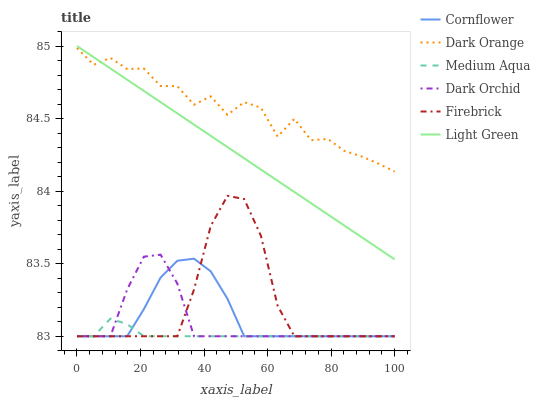Does Medium Aqua have the minimum area under the curve?
Answer yes or no. Yes. Does Dark Orange have the maximum area under the curve?
Answer yes or no. Yes. Does Firebrick have the minimum area under the curve?
Answer yes or no. No. Does Firebrick have the maximum area under the curve?
Answer yes or no. No. Is Light Green the smoothest?
Answer yes or no. Yes. Is Dark Orange the roughest?
Answer yes or no. Yes. Is Firebrick the smoothest?
Answer yes or no. No. Is Firebrick the roughest?
Answer yes or no. No. Does Cornflower have the lowest value?
Answer yes or no. Yes. Does Dark Orange have the lowest value?
Answer yes or no. No. Does Light Green have the highest value?
Answer yes or no. Yes. Does Dark Orange have the highest value?
Answer yes or no. No. Is Firebrick less than Dark Orange?
Answer yes or no. Yes. Is Dark Orange greater than Dark Orchid?
Answer yes or no. Yes. Does Firebrick intersect Dark Orchid?
Answer yes or no. Yes. Is Firebrick less than Dark Orchid?
Answer yes or no. No. Is Firebrick greater than Dark Orchid?
Answer yes or no. No. Does Firebrick intersect Dark Orange?
Answer yes or no. No. 